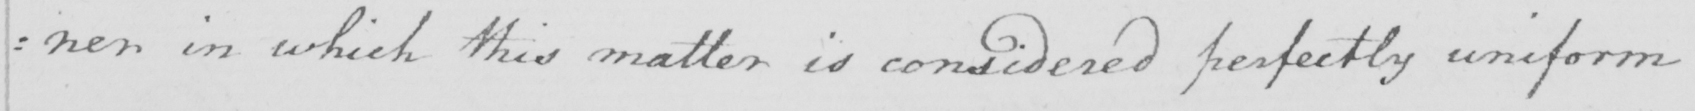Can you read and transcribe this handwriting? : ner in which this matter is considered perfectly uniform 